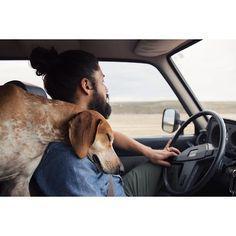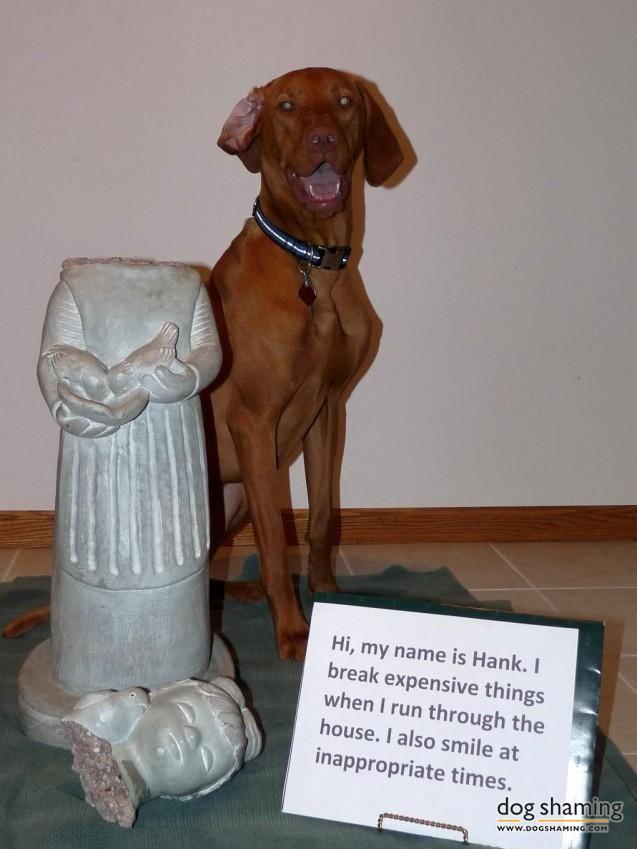The first image is the image on the left, the second image is the image on the right. Examine the images to the left and right. Is the description "One image shows a dog wearing a harness and the other shows a dog wearing a shirt." accurate? Answer yes or no. No. The first image is the image on the left, the second image is the image on the right. For the images shown, is this caption "One dog is wearing a sweater." true? Answer yes or no. No. 